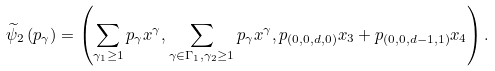Convert formula to latex. <formula><loc_0><loc_0><loc_500><loc_500>\widetilde { \psi } _ { 2 } \left ( p _ { \gamma } \right ) = \left ( \sum _ { \gamma _ { 1 } \geq 1 } p _ { \gamma } x ^ { \gamma } , \sum _ { \gamma \in \Gamma _ { 1 } , \gamma _ { 2 } \geq 1 } p _ { \gamma } x ^ { \gamma } , p _ { ( 0 , 0 , d , 0 ) } x _ { 3 } + p _ { ( 0 , 0 , d - 1 , 1 ) } x _ { 4 } \right ) .</formula> 